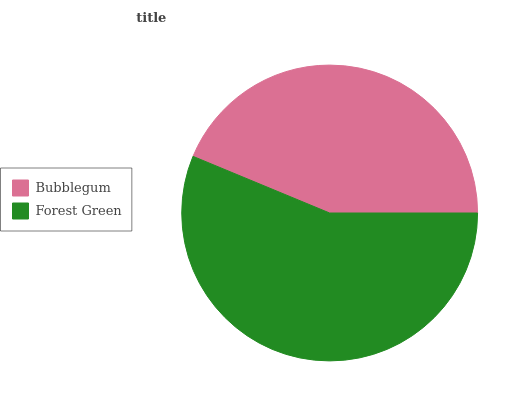Is Bubblegum the minimum?
Answer yes or no. Yes. Is Forest Green the maximum?
Answer yes or no. Yes. Is Forest Green the minimum?
Answer yes or no. No. Is Forest Green greater than Bubblegum?
Answer yes or no. Yes. Is Bubblegum less than Forest Green?
Answer yes or no. Yes. Is Bubblegum greater than Forest Green?
Answer yes or no. No. Is Forest Green less than Bubblegum?
Answer yes or no. No. Is Forest Green the high median?
Answer yes or no. Yes. Is Bubblegum the low median?
Answer yes or no. Yes. Is Bubblegum the high median?
Answer yes or no. No. Is Forest Green the low median?
Answer yes or no. No. 